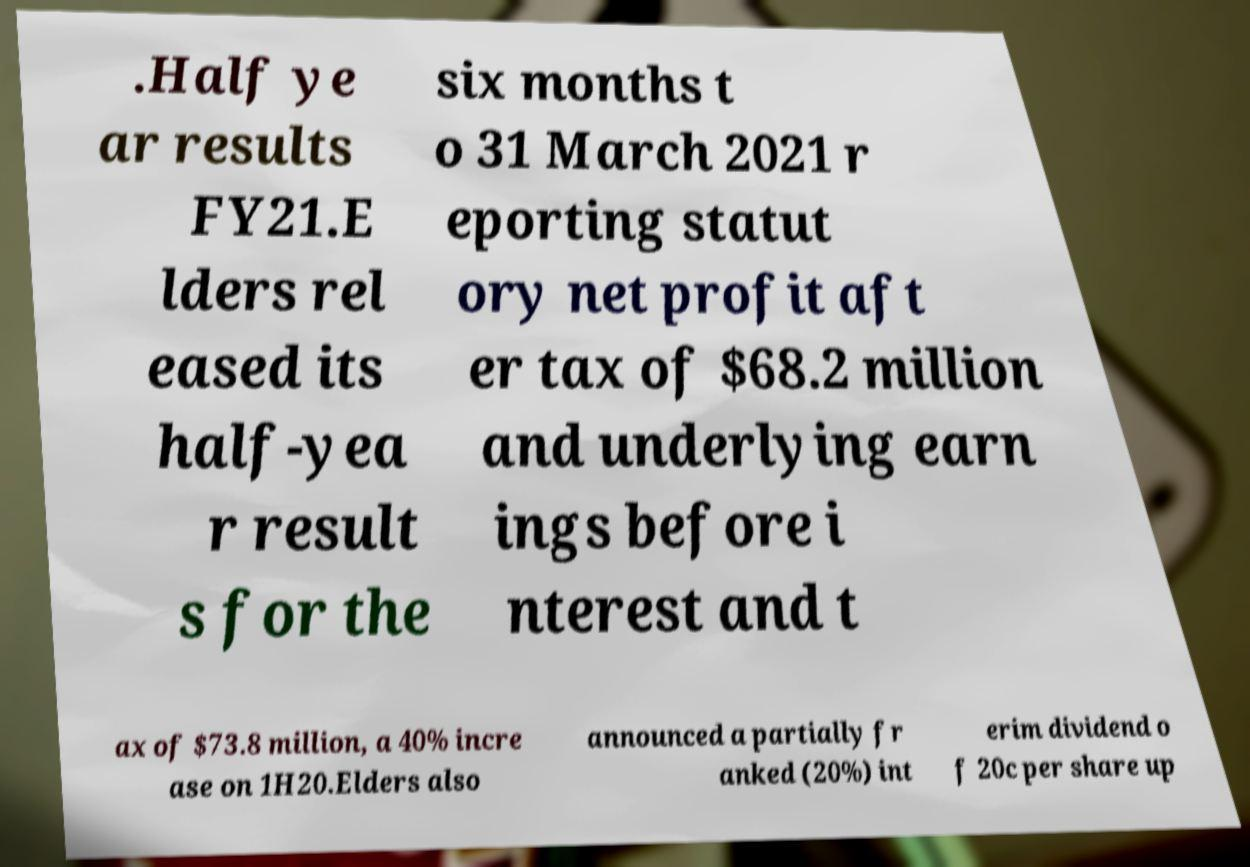Could you assist in decoding the text presented in this image and type it out clearly? .Half ye ar results FY21.E lders rel eased its half-yea r result s for the six months t o 31 March 2021 r eporting statut ory net profit aft er tax of $68.2 million and underlying earn ings before i nterest and t ax of $73.8 million, a 40% incre ase on 1H20.Elders also announced a partially fr anked (20%) int erim dividend o f 20c per share up 